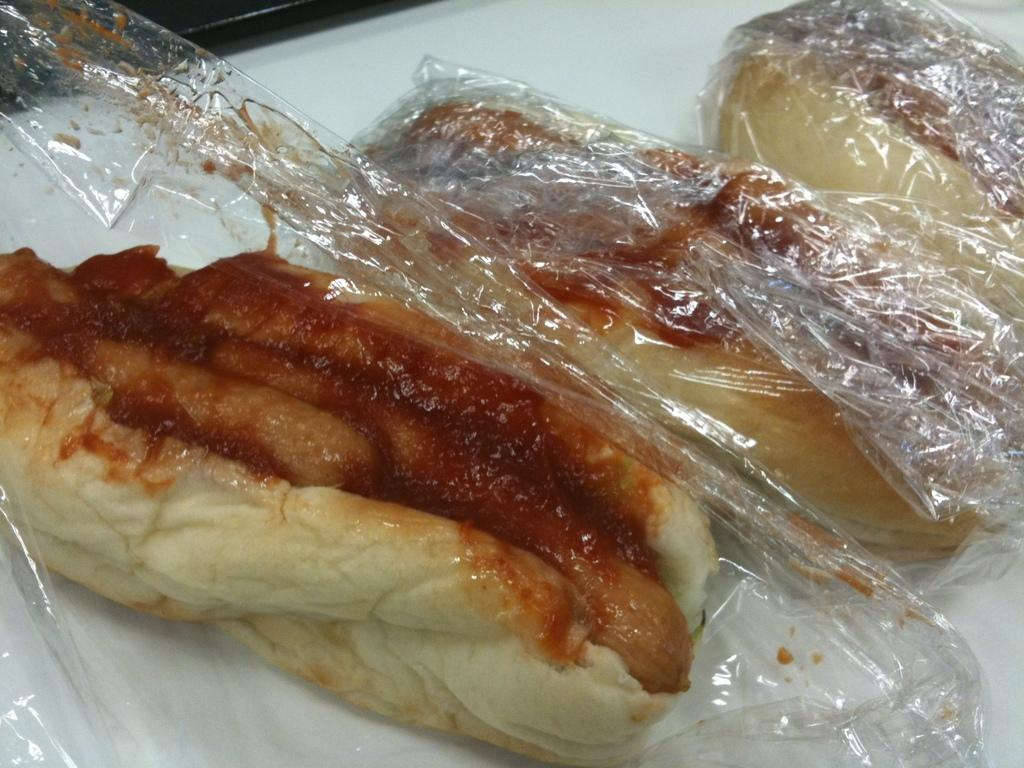What type of food can be seen in the image? There are sandwiches and hot dogs in the image. What condiment is visible in the image? Ketchup is present in the image. Where are the sandwiches and hot dogs located? The sandwiches and hot dogs are on a table. What type of hose can be seen in the image? There is no hose present in the image. Can you describe the branch that is holding up the kite in the image? There is no branch or kite present in the image. 